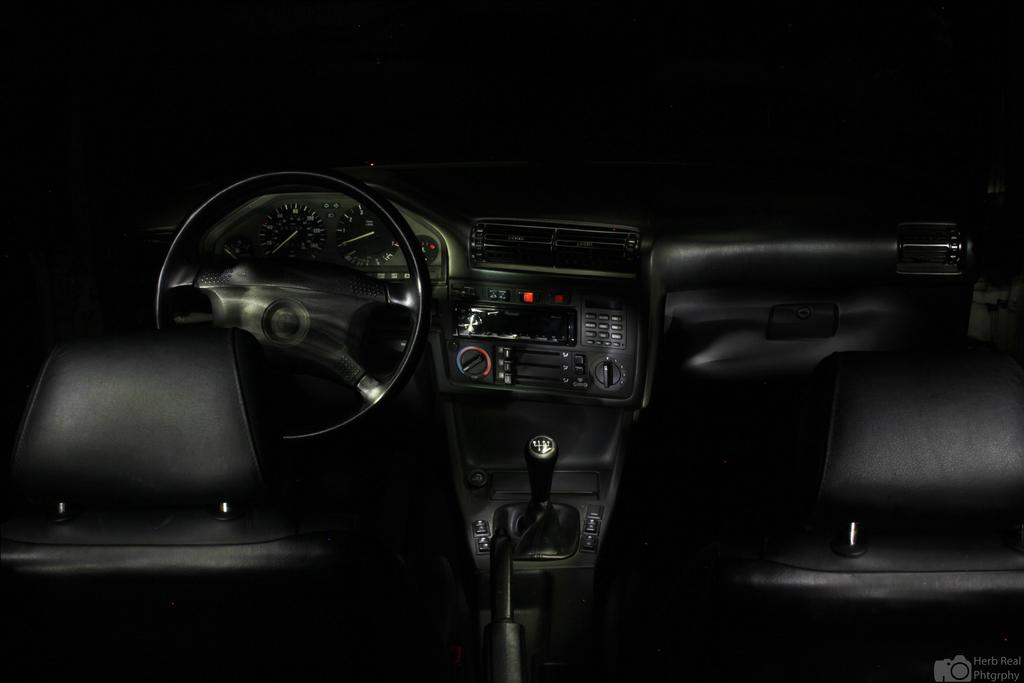What is the main subject of the image? The main subject of the image is a vehicle. What feature is present in the vehicle? The vehicle has a steering wheel. What type of prose can be seen in the image? There is no prose present in the image; it features a vehicle with a steering wheel. How many boats are visible in the image? There are no boats visible in the image; it features a vehicle with a steering wheel. 